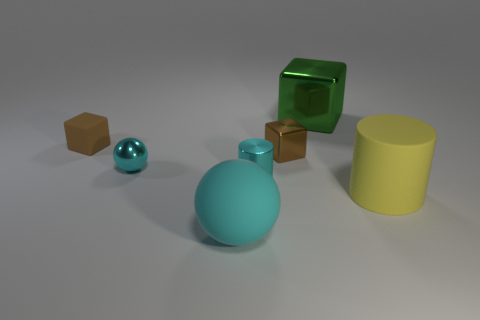There is a object that is both left of the big green metal block and in front of the metallic cylinder; what material is it?
Give a very brief answer. Rubber. Is there anything else that has the same size as the yellow rubber cylinder?
Offer a very short reply. Yes. Is the color of the tiny sphere the same as the tiny shiny cylinder?
Provide a succinct answer. Yes. There is a tiny object that is the same color as the shiny cylinder; what shape is it?
Ensure brevity in your answer.  Sphere. What number of other metallic things are the same shape as the tiny brown shiny thing?
Your response must be concise. 1. There is a cyan sphere that is made of the same material as the big yellow cylinder; what size is it?
Your answer should be very brief. Large. Is the size of the cyan rubber sphere the same as the brown metal cube?
Provide a short and direct response. No. Are there any cyan objects?
Provide a short and direct response. Yes. What is the size of the metal thing that is the same color as the tiny metal cylinder?
Keep it short and to the point. Small. What is the size of the shiny object that is on the left side of the cylinder to the left of the large yellow rubber cylinder to the right of the tiny cyan ball?
Your answer should be compact. Small. 